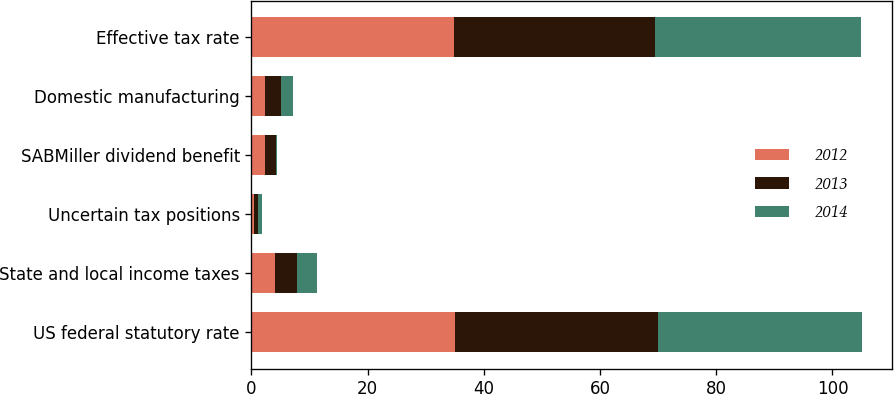Convert chart. <chart><loc_0><loc_0><loc_500><loc_500><stacked_bar_chart><ecel><fcel>US federal statutory rate<fcel>State and local income taxes<fcel>Uncertain tax positions<fcel>SABMiller dividend benefit<fcel>Domestic manufacturing<fcel>Effective tax rate<nl><fcel>2012<fcel>35<fcel>4<fcel>0.5<fcel>2.3<fcel>2.4<fcel>34.8<nl><fcel>2013<fcel>35<fcel>3.8<fcel>0.7<fcel>2<fcel>2.7<fcel>34.7<nl><fcel>2014<fcel>35<fcel>3.5<fcel>0.7<fcel>0.1<fcel>2<fcel>35.4<nl></chart> 